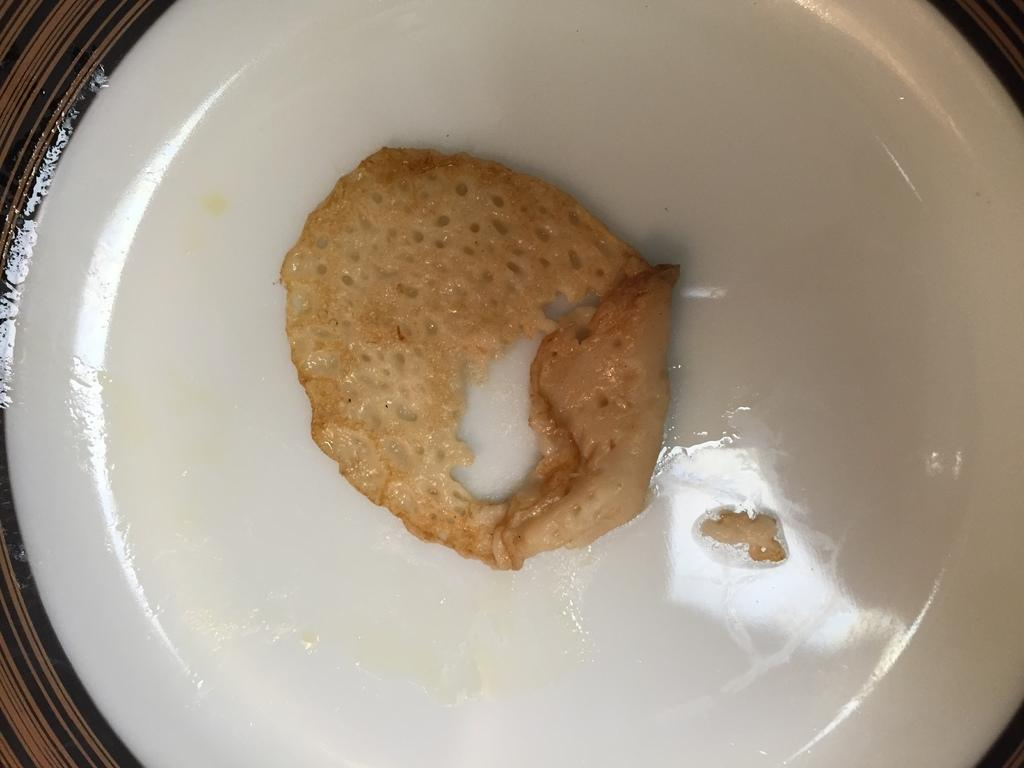What is the main subject of the image? There is a food item in the image. How is the food item presented in the image? The food item is in a plate. What impulse does the food item have in the image? There is no indication of any impulse or movement of the food item in the image; it is stationary in the plate. 